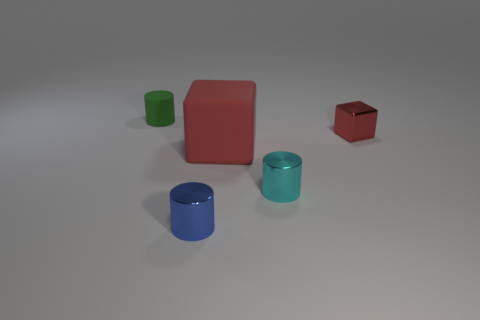Are there any other things that have the same size as the red matte thing?
Offer a very short reply. No. Do the small red thing and the small rubber object have the same shape?
Provide a short and direct response. No. Is there a metallic cylinder that is behind the metal object on the left side of the red rubber block?
Provide a short and direct response. Yes. Are there an equal number of small shiny blocks in front of the blue cylinder and yellow shiny cylinders?
Your answer should be compact. Yes. How many other things are the same size as the matte block?
Keep it short and to the point. 0. Is the large red block behind the cyan metal object made of the same material as the object behind the small metallic block?
Keep it short and to the point. Yes. There is a rubber object behind the rubber thing in front of the red metallic cube; what is its size?
Make the answer very short. Small. Are there any tiny metal objects that have the same color as the large matte object?
Keep it short and to the point. Yes. There is a cylinder that is behind the large red rubber thing; is its color the same as the small shiny cylinder that is on the right side of the big red block?
Provide a succinct answer. No. The blue metal object has what shape?
Give a very brief answer. Cylinder. 